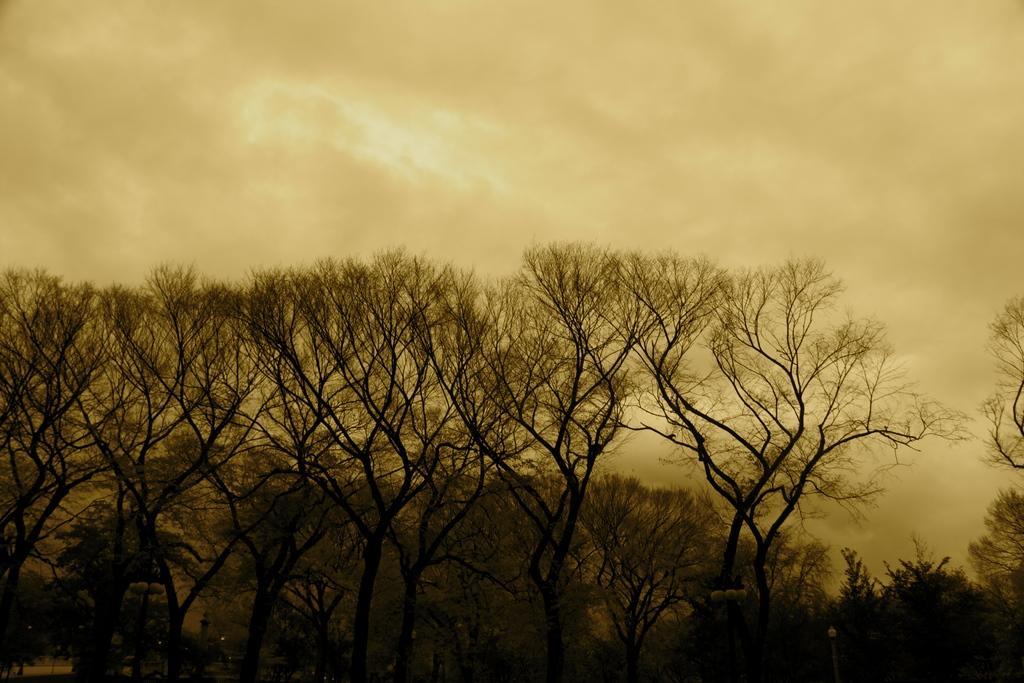Describe this image in one or two sentences. There are trees and plants on the ground. In the background, there are clouds in the sky. 